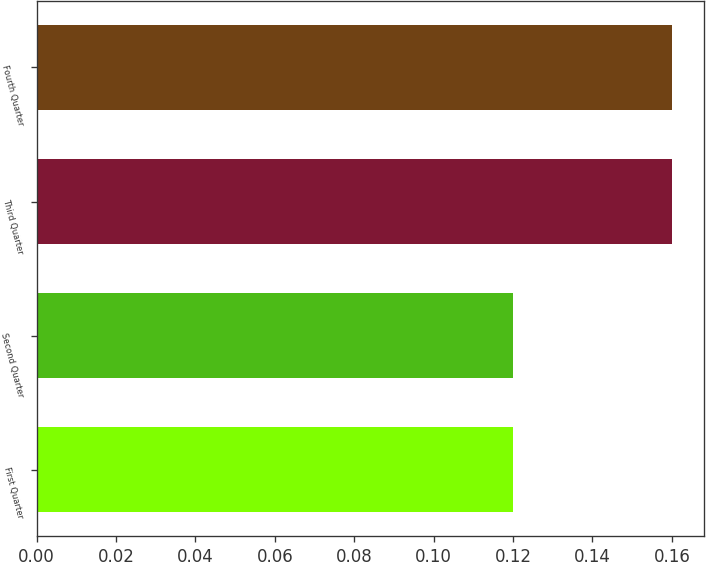Convert chart to OTSL. <chart><loc_0><loc_0><loc_500><loc_500><bar_chart><fcel>First Quarter<fcel>Second Quarter<fcel>Third Quarter<fcel>Fourth Quarter<nl><fcel>0.12<fcel>0.12<fcel>0.16<fcel>0.16<nl></chart> 